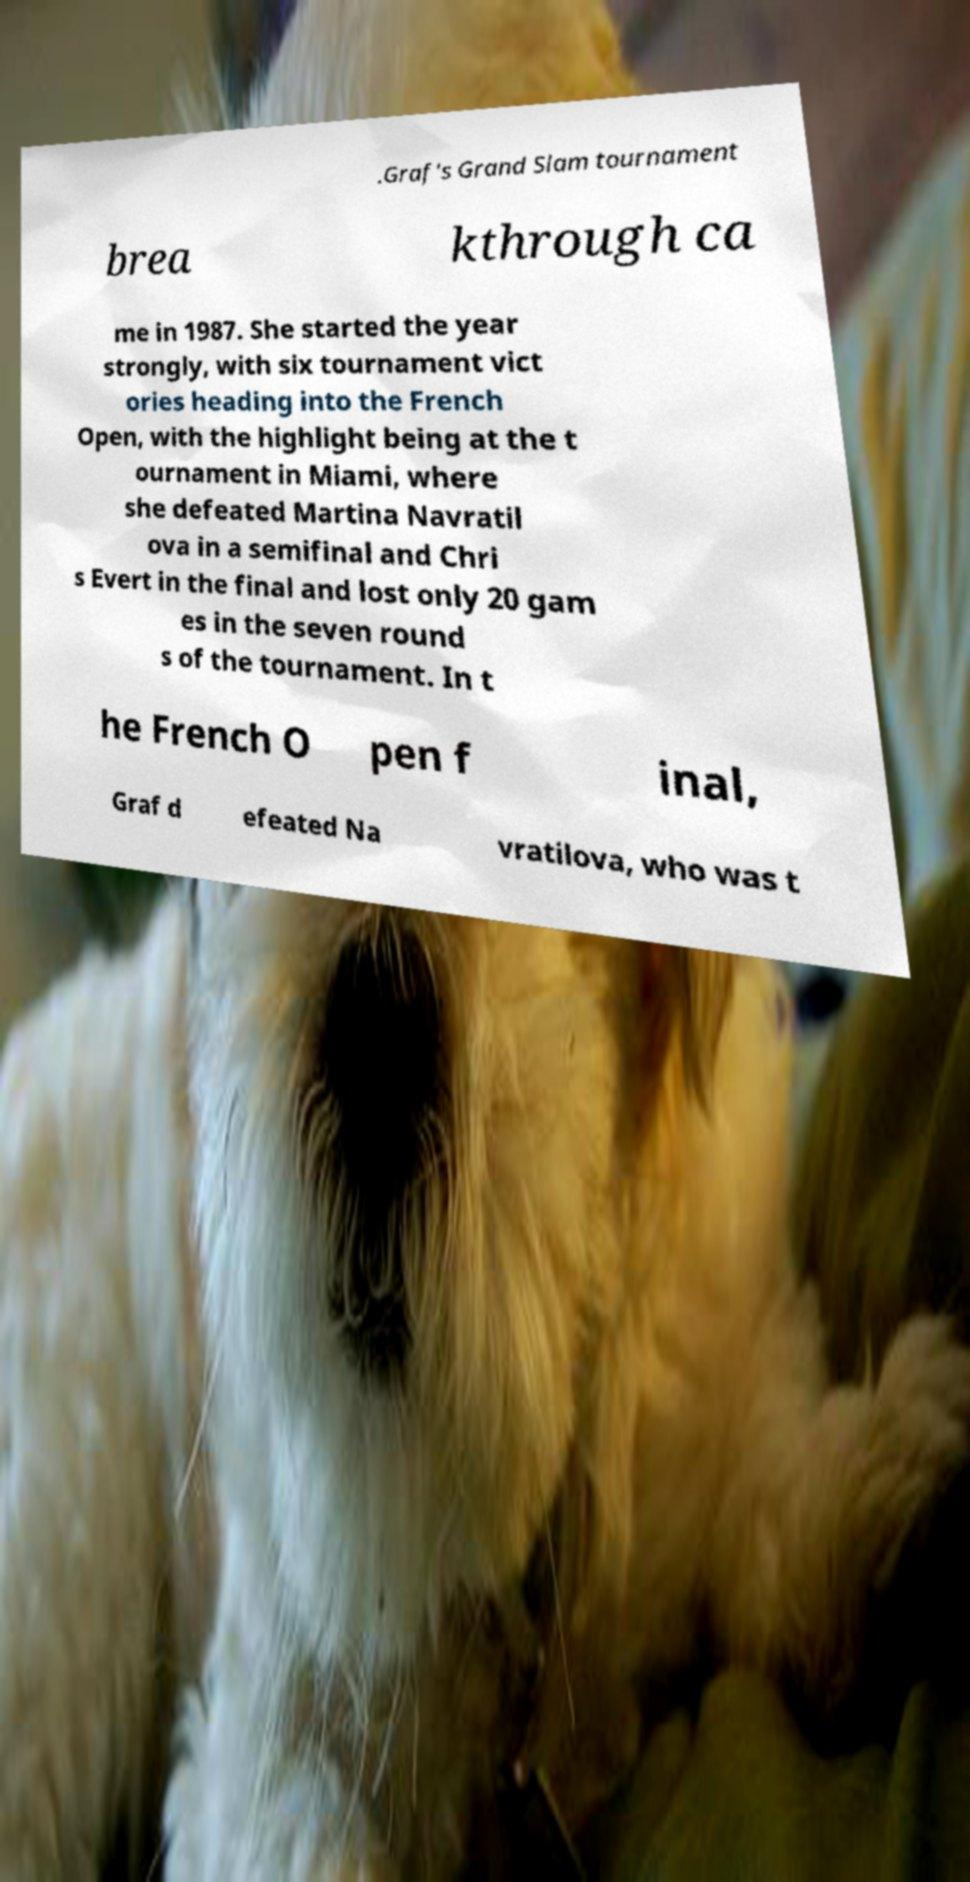Can you accurately transcribe the text from the provided image for me? .Graf's Grand Slam tournament brea kthrough ca me in 1987. She started the year strongly, with six tournament vict ories heading into the French Open, with the highlight being at the t ournament in Miami, where she defeated Martina Navratil ova in a semifinal and Chri s Evert in the final and lost only 20 gam es in the seven round s of the tournament. In t he French O pen f inal, Graf d efeated Na vratilova, who was t 